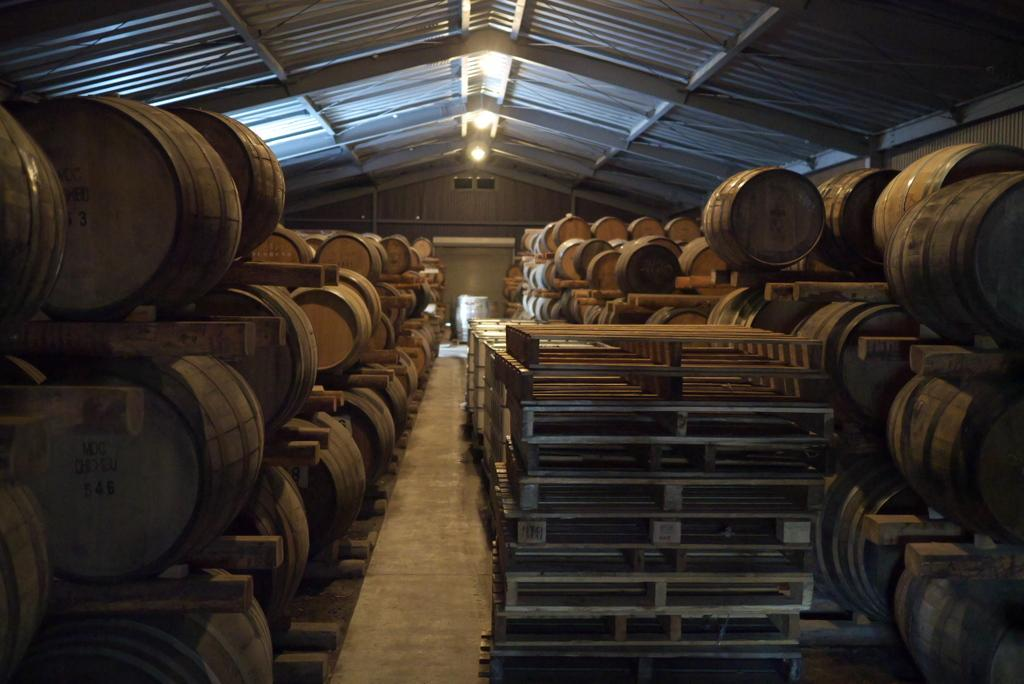What type of musical instruments are in the image? There are drums in the image. What material are some of the items in the image made of? There are metal items in the image. Where are the drums and metal items located? The drums and metal items are kept under a shed. What is on the roof of the shed? There is a light on the roof of the shed. Can you see any sticks with wings in the image? There are no sticks or wings present in the image. 